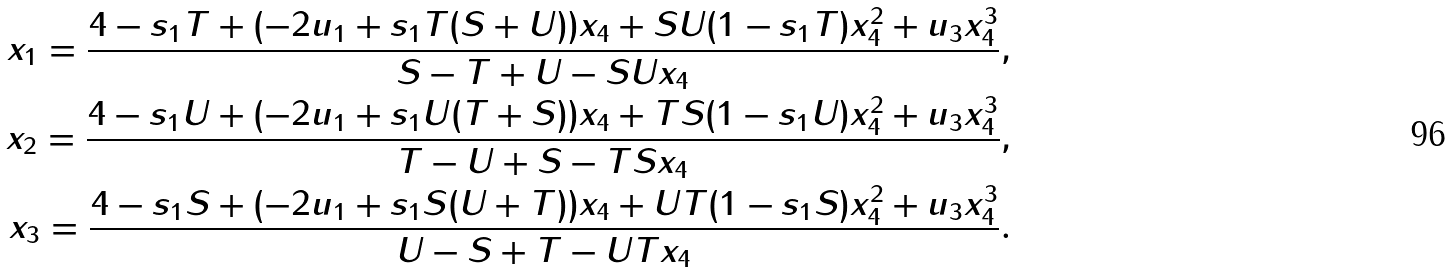<formula> <loc_0><loc_0><loc_500><loc_500>x _ { 1 } = \frac { 4 - s _ { 1 } T + ( - 2 u _ { 1 } + s _ { 1 } T ( S + U ) ) x _ { 4 } + S U ( 1 - s _ { 1 } T ) x _ { 4 } ^ { 2 } + u _ { 3 } x _ { 4 } ^ { 3 } } { S - T + U - S U x _ { 4 } } , \\ x _ { 2 } = \frac { 4 - s _ { 1 } U + ( - 2 u _ { 1 } + s _ { 1 } U ( T + S ) ) x _ { 4 } + T S ( 1 - s _ { 1 } U ) x _ { 4 } ^ { 2 } + u _ { 3 } x _ { 4 } ^ { 3 } } { T - U + S - T S x _ { 4 } } , \\ x _ { 3 } = \frac { 4 - s _ { 1 } S + ( - 2 u _ { 1 } + s _ { 1 } S ( U + T ) ) x _ { 4 } + U T ( 1 - s _ { 1 } S ) x _ { 4 } ^ { 2 } + u _ { 3 } x _ { 4 } ^ { 3 } } { U - S + T - U T x _ { 4 } } .</formula> 